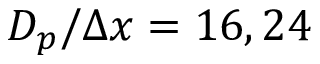<formula> <loc_0><loc_0><loc_500><loc_500>D _ { p } / \Delta x = 1 6 , 2 4</formula> 